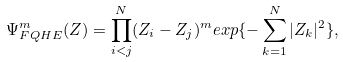<formula> <loc_0><loc_0><loc_500><loc_500>\Psi _ { F Q H E } ^ { m } ( Z ) = \prod _ { i < j } ^ { N } ( Z _ { i } - Z _ { j } ) ^ { m } e x p \{ - \sum _ { k = 1 } ^ { N } | Z _ { k } | ^ { 2 } \} ,</formula> 